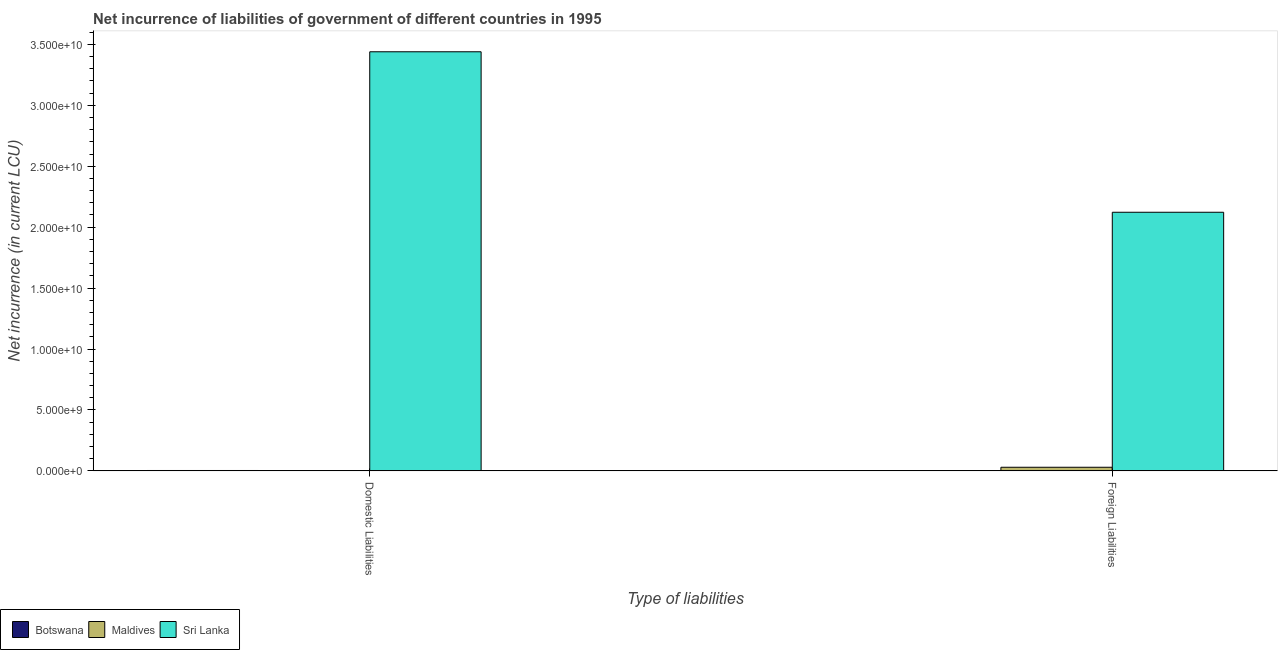How many groups of bars are there?
Ensure brevity in your answer.  2. Are the number of bars per tick equal to the number of legend labels?
Make the answer very short. No. What is the label of the 1st group of bars from the left?
Keep it short and to the point. Domestic Liabilities. What is the net incurrence of domestic liabilities in Sri Lanka?
Ensure brevity in your answer.  3.44e+1. Across all countries, what is the maximum net incurrence of domestic liabilities?
Your answer should be compact. 3.44e+1. Across all countries, what is the minimum net incurrence of domestic liabilities?
Make the answer very short. 4.50e+06. In which country was the net incurrence of foreign liabilities maximum?
Your response must be concise. Sri Lanka. What is the total net incurrence of domestic liabilities in the graph?
Provide a succinct answer. 3.44e+1. What is the difference between the net incurrence of domestic liabilities in Botswana and that in Sri Lanka?
Provide a succinct answer. -3.44e+1. What is the difference between the net incurrence of domestic liabilities in Botswana and the net incurrence of foreign liabilities in Sri Lanka?
Your answer should be very brief. -2.12e+1. What is the average net incurrence of foreign liabilities per country?
Give a very brief answer. 7.17e+09. What is the difference between the net incurrence of domestic liabilities and net incurrence of foreign liabilities in Maldives?
Provide a succinct answer. -2.94e+08. In how many countries, is the net incurrence of foreign liabilities greater than 30000000000 LCU?
Keep it short and to the point. 0. What is the ratio of the net incurrence of domestic liabilities in Sri Lanka to that in Botswana?
Offer a very short reply. 1048.57. In how many countries, is the net incurrence of domestic liabilities greater than the average net incurrence of domestic liabilities taken over all countries?
Keep it short and to the point. 1. Are all the bars in the graph horizontal?
Make the answer very short. No. What is the difference between two consecutive major ticks on the Y-axis?
Ensure brevity in your answer.  5.00e+09. Are the values on the major ticks of Y-axis written in scientific E-notation?
Ensure brevity in your answer.  Yes. Does the graph contain any zero values?
Keep it short and to the point. Yes. Does the graph contain grids?
Your answer should be compact. No. Where does the legend appear in the graph?
Provide a succinct answer. Bottom left. What is the title of the graph?
Your answer should be very brief. Net incurrence of liabilities of government of different countries in 1995. Does "San Marino" appear as one of the legend labels in the graph?
Offer a terse response. No. What is the label or title of the X-axis?
Ensure brevity in your answer.  Type of liabilities. What is the label or title of the Y-axis?
Ensure brevity in your answer.  Net incurrence (in current LCU). What is the Net incurrence (in current LCU) of Botswana in Domestic Liabilities?
Make the answer very short. 3.28e+07. What is the Net incurrence (in current LCU) of Maldives in Domestic Liabilities?
Your answer should be very brief. 4.50e+06. What is the Net incurrence (in current LCU) of Sri Lanka in Domestic Liabilities?
Give a very brief answer. 3.44e+1. What is the Net incurrence (in current LCU) of Botswana in Foreign Liabilities?
Provide a short and direct response. 0. What is the Net incurrence (in current LCU) of Maldives in Foreign Liabilities?
Keep it short and to the point. 2.98e+08. What is the Net incurrence (in current LCU) in Sri Lanka in Foreign Liabilities?
Your answer should be very brief. 2.12e+1. Across all Type of liabilities, what is the maximum Net incurrence (in current LCU) in Botswana?
Offer a very short reply. 3.28e+07. Across all Type of liabilities, what is the maximum Net incurrence (in current LCU) of Maldives?
Offer a terse response. 2.98e+08. Across all Type of liabilities, what is the maximum Net incurrence (in current LCU) in Sri Lanka?
Provide a succinct answer. 3.44e+1. Across all Type of liabilities, what is the minimum Net incurrence (in current LCU) in Botswana?
Your answer should be compact. 0. Across all Type of liabilities, what is the minimum Net incurrence (in current LCU) of Maldives?
Offer a very short reply. 4.50e+06. Across all Type of liabilities, what is the minimum Net incurrence (in current LCU) in Sri Lanka?
Provide a succinct answer. 2.12e+1. What is the total Net incurrence (in current LCU) in Botswana in the graph?
Offer a terse response. 3.28e+07. What is the total Net incurrence (in current LCU) in Maldives in the graph?
Offer a very short reply. 3.02e+08. What is the total Net incurrence (in current LCU) in Sri Lanka in the graph?
Ensure brevity in your answer.  5.56e+1. What is the difference between the Net incurrence (in current LCU) in Maldives in Domestic Liabilities and that in Foreign Liabilities?
Give a very brief answer. -2.94e+08. What is the difference between the Net incurrence (in current LCU) of Sri Lanka in Domestic Liabilities and that in Foreign Liabilities?
Ensure brevity in your answer.  1.32e+1. What is the difference between the Net incurrence (in current LCU) of Botswana in Domestic Liabilities and the Net incurrence (in current LCU) of Maldives in Foreign Liabilities?
Provide a succinct answer. -2.65e+08. What is the difference between the Net incurrence (in current LCU) in Botswana in Domestic Liabilities and the Net incurrence (in current LCU) in Sri Lanka in Foreign Liabilities?
Offer a very short reply. -2.12e+1. What is the difference between the Net incurrence (in current LCU) in Maldives in Domestic Liabilities and the Net incurrence (in current LCU) in Sri Lanka in Foreign Liabilities?
Give a very brief answer. -2.12e+1. What is the average Net incurrence (in current LCU) of Botswana per Type of liabilities?
Your answer should be very brief. 1.64e+07. What is the average Net incurrence (in current LCU) in Maldives per Type of liabilities?
Offer a very short reply. 1.51e+08. What is the average Net incurrence (in current LCU) of Sri Lanka per Type of liabilities?
Give a very brief answer. 2.78e+1. What is the difference between the Net incurrence (in current LCU) of Botswana and Net incurrence (in current LCU) of Maldives in Domestic Liabilities?
Ensure brevity in your answer.  2.83e+07. What is the difference between the Net incurrence (in current LCU) in Botswana and Net incurrence (in current LCU) in Sri Lanka in Domestic Liabilities?
Offer a terse response. -3.44e+1. What is the difference between the Net incurrence (in current LCU) of Maldives and Net incurrence (in current LCU) of Sri Lanka in Domestic Liabilities?
Ensure brevity in your answer.  -3.44e+1. What is the difference between the Net incurrence (in current LCU) in Maldives and Net incurrence (in current LCU) in Sri Lanka in Foreign Liabilities?
Provide a short and direct response. -2.09e+1. What is the ratio of the Net incurrence (in current LCU) of Maldives in Domestic Liabilities to that in Foreign Liabilities?
Make the answer very short. 0.02. What is the ratio of the Net incurrence (in current LCU) in Sri Lanka in Domestic Liabilities to that in Foreign Liabilities?
Offer a terse response. 1.62. What is the difference between the highest and the second highest Net incurrence (in current LCU) of Maldives?
Make the answer very short. 2.94e+08. What is the difference between the highest and the second highest Net incurrence (in current LCU) in Sri Lanka?
Make the answer very short. 1.32e+1. What is the difference between the highest and the lowest Net incurrence (in current LCU) in Botswana?
Provide a short and direct response. 3.28e+07. What is the difference between the highest and the lowest Net incurrence (in current LCU) in Maldives?
Give a very brief answer. 2.94e+08. What is the difference between the highest and the lowest Net incurrence (in current LCU) of Sri Lanka?
Keep it short and to the point. 1.32e+1. 